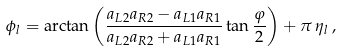Convert formula to latex. <formula><loc_0><loc_0><loc_500><loc_500>\phi _ { l } = \arctan \left ( \frac { a _ { L 2 } a _ { R 2 } - a _ { L 1 } a _ { R 1 } } { a _ { L 2 } a _ { R 2 } + a _ { L 1 } a _ { R 1 } } \tan \frac { \varphi } { 2 } \right ) + \pi \, \eta _ { l } \, ,</formula> 